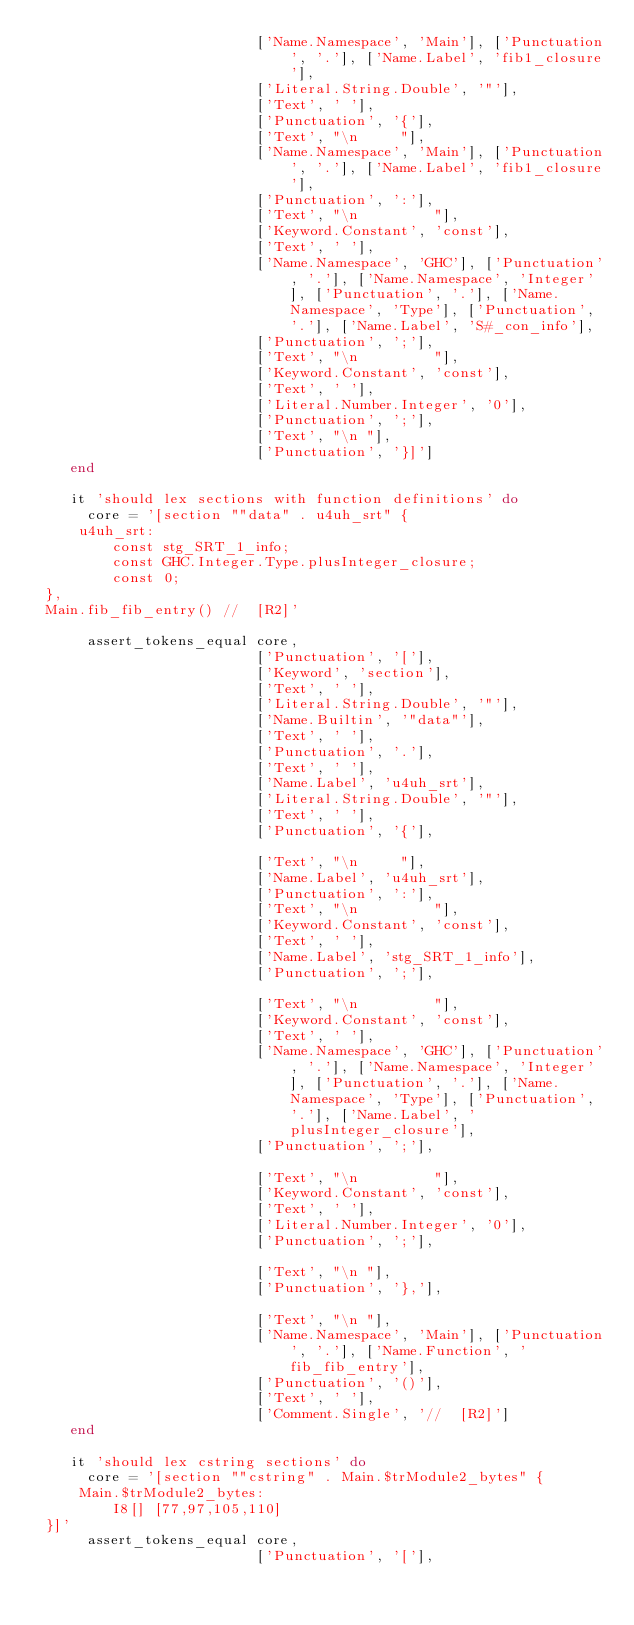Convert code to text. <code><loc_0><loc_0><loc_500><loc_500><_Ruby_>                          ['Name.Namespace', 'Main'], ['Punctuation', '.'], ['Name.Label', 'fib1_closure'],
                          ['Literal.String.Double', '"'],
                          ['Text', ' '],
                          ['Punctuation', '{'],
                          ['Text', "\n     "],
                          ['Name.Namespace', 'Main'], ['Punctuation', '.'], ['Name.Label', 'fib1_closure'],
                          ['Punctuation', ':'],
                          ['Text', "\n         "],
                          ['Keyword.Constant', 'const'],
                          ['Text', ' '],
                          ['Name.Namespace', 'GHC'], ['Punctuation', '.'], ['Name.Namespace', 'Integer'], ['Punctuation', '.'], ['Name.Namespace', 'Type'], ['Punctuation', '.'], ['Name.Label', 'S#_con_info'],
                          ['Punctuation', ';'],
                          ['Text', "\n         "],
                          ['Keyword.Constant', 'const'],
                          ['Text', ' '],
                          ['Literal.Number.Integer', '0'],
                          ['Punctuation', ';'],
                          ['Text', "\n "],
                          ['Punctuation', '}]']
    end

    it 'should lex sections with function definitions' do
      core = '[section ""data" . u4uh_srt" {
     u4uh_srt:
         const stg_SRT_1_info;
         const GHC.Integer.Type.plusInteger_closure;
         const 0;
 },
 Main.fib_fib_entry() //  [R2]'

      assert_tokens_equal core,
                          ['Punctuation', '['],
                          ['Keyword', 'section'],
                          ['Text', ' '],
                          ['Literal.String.Double', '"'],
                          ['Name.Builtin', '"data"'],
                          ['Text', ' '],
                          ['Punctuation', '.'],
                          ['Text', ' '],
                          ['Name.Label', 'u4uh_srt'],
                          ['Literal.String.Double', '"'],
                          ['Text', ' '],
                          ['Punctuation', '{'],

                          ['Text', "\n     "],
                          ['Name.Label', 'u4uh_srt'],
                          ['Punctuation', ':'],
                          ['Text', "\n         "],
                          ['Keyword.Constant', 'const'],
                          ['Text', ' '],
                          ['Name.Label', 'stg_SRT_1_info'],
                          ['Punctuation', ';'],

                          ['Text', "\n         "],
                          ['Keyword.Constant', 'const'],
                          ['Text', ' '],
                          ['Name.Namespace', 'GHC'], ['Punctuation', '.'], ['Name.Namespace', 'Integer'], ['Punctuation', '.'], ['Name.Namespace', 'Type'], ['Punctuation', '.'], ['Name.Label', 'plusInteger_closure'],
                          ['Punctuation', ';'],

                          ['Text', "\n         "],
                          ['Keyword.Constant', 'const'],
                          ['Text', ' '],
                          ['Literal.Number.Integer', '0'],
                          ['Punctuation', ';'],

                          ['Text', "\n "],
                          ['Punctuation', '},'],

                          ['Text', "\n "],
                          ['Name.Namespace', 'Main'], ['Punctuation', '.'], ['Name.Function', 'fib_fib_entry'],
                          ['Punctuation', '()'],
                          ['Text', ' '],
                          ['Comment.Single', '//  [R2]']
    end

    it 'should lex cstring sections' do
      core = '[section ""cstring" . Main.$trModule2_bytes" {
     Main.$trModule2_bytes:
         I8[] [77,97,105,110]
 }]'
      assert_tokens_equal core,
                          ['Punctuation', '['],</code> 